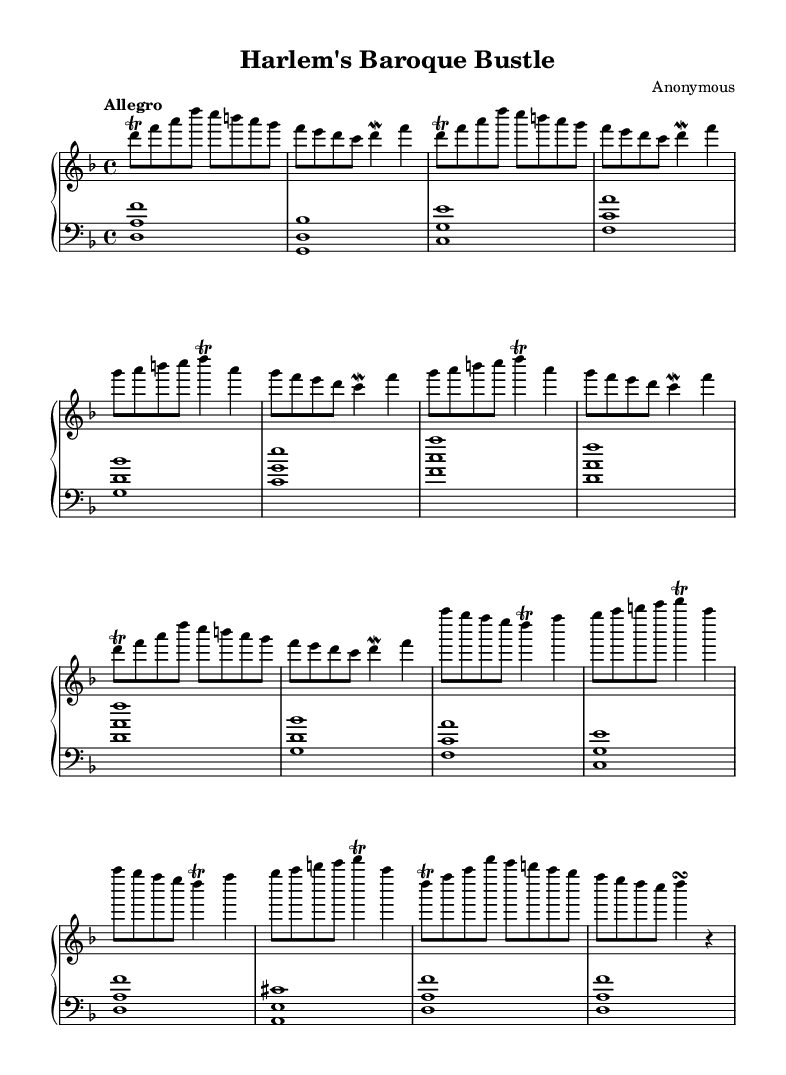What is the key signature of this music? The key signature is D minor, which has one flat (B flat). This can be identified at the beginning of the sheet music after the clef sign.
Answer: D minor What is the time signature of this composition? The time signature is 4/4, indicating that there are four beats in a measure and a quarter note gets one beat. This is visible right after the key signature.
Answer: 4/4 What is the tempo marking for this piece? The tempo marking is "Allegro," which suggests a fast-paced performance. This is located above the staff at the beginning of the sheet music.
Answer: Allegro How many sections does the piece contain? The piece contains three distinct sections labeled A, B, and C, with the A section repeated partially at the end. This can be discerned from the layout and structure of the music.
Answer: Three What type of ornamentation is used in the upper part of the music? The upper part features trills and mordents, which are common baroque ornamentations, seen throughout the melody lines. Identifying these can be done through observing the specific symbols placed above certain notes.
Answer: Trills and mordents What is the nature of the harmony in the lower part of the music? The harmony is structured using root position chords, which create a solid harmonic foundation, evident from the chord placements in the bass staff.
Answer: Root position chords What stylistic feature is prominent in this Harpsichord composition? The piece prominently features ornamentation, which is characteristic of Baroque music, enhancing expression and complexity in the performance. This can be concluded by the frequent appearance of trills and mordents in the melody.
Answer: Ornamentation 